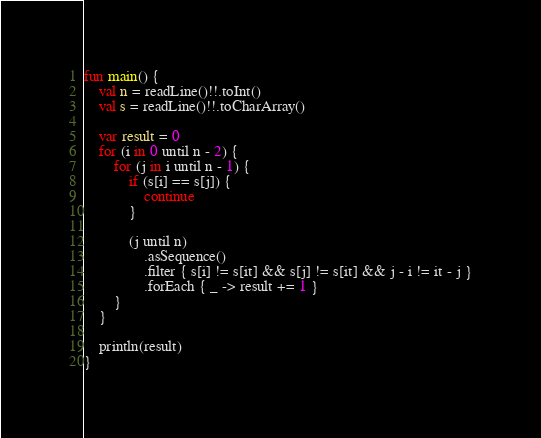Convert code to text. <code><loc_0><loc_0><loc_500><loc_500><_Kotlin_>fun main() {
    val n = readLine()!!.toInt()
    val s = readLine()!!.toCharArray()

    var result = 0
    for (i in 0 until n - 2) {
        for (j in i until n - 1) {
            if (s[i] == s[j]) {
                continue
            }
    
            (j until n)
                .asSequence()
                .filter { s[i] != s[it] && s[j] != s[it] && j - i != it - j }
                .forEach { _ -> result += 1 }
        }
    }

    println(result)
}</code> 